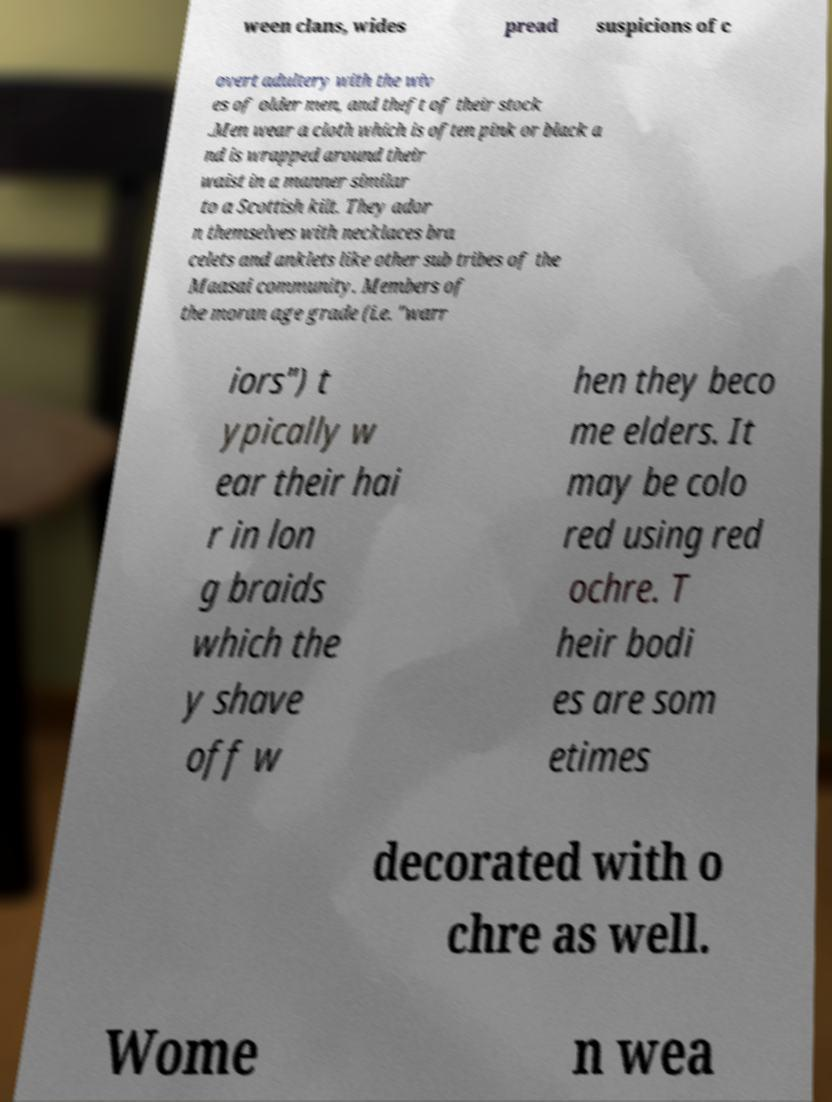There's text embedded in this image that I need extracted. Can you transcribe it verbatim? ween clans, wides pread suspicions of c overt adultery with the wiv es of older men, and theft of their stock .Men wear a cloth which is often pink or black a nd is wrapped around their waist in a manner similar to a Scottish kilt. They ador n themselves with necklaces bra celets and anklets like other sub tribes of the Maasai community. Members of the moran age grade (i.e. "warr iors") t ypically w ear their hai r in lon g braids which the y shave off w hen they beco me elders. It may be colo red using red ochre. T heir bodi es are som etimes decorated with o chre as well. Wome n wea 